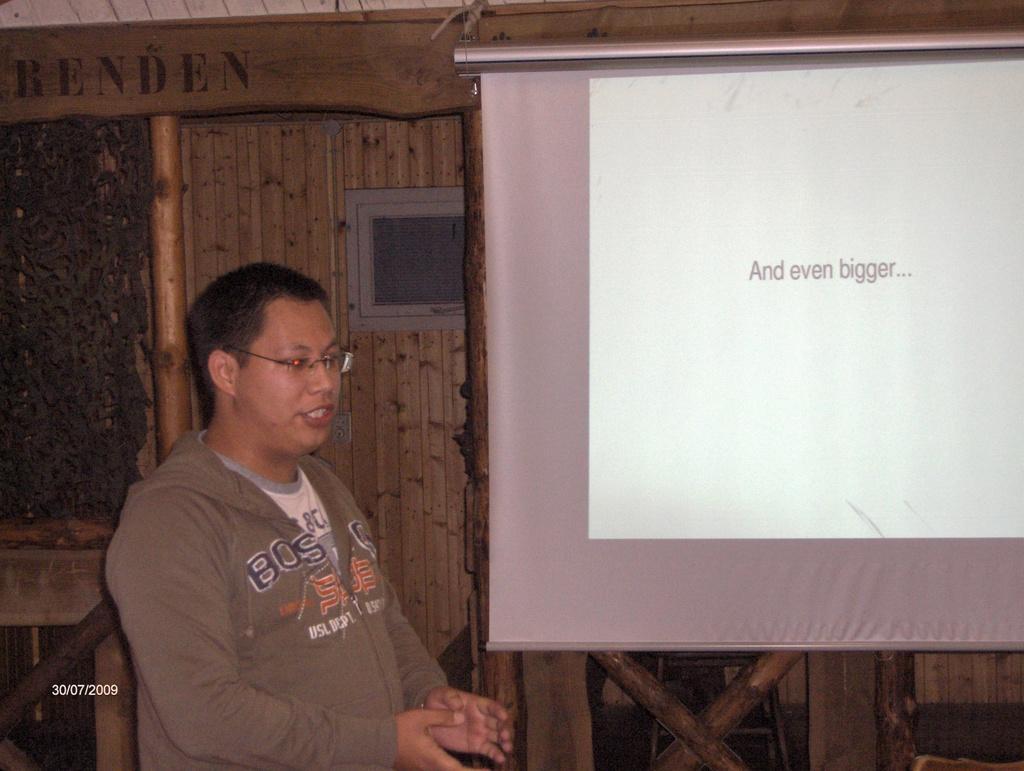How would you summarize this image in a sentence or two? In this image, I can see the man standing. This looks like a screen with the display. Here is the window. I think this is a name board. At the bottom of the image, I can see the watermark. 